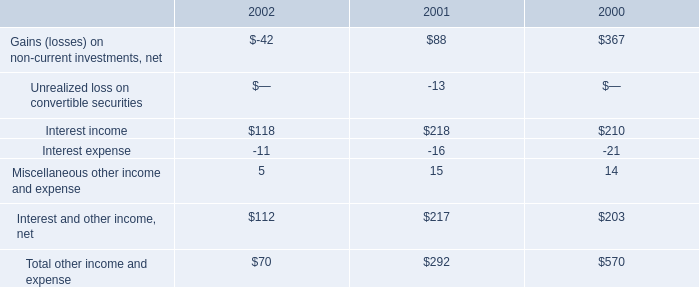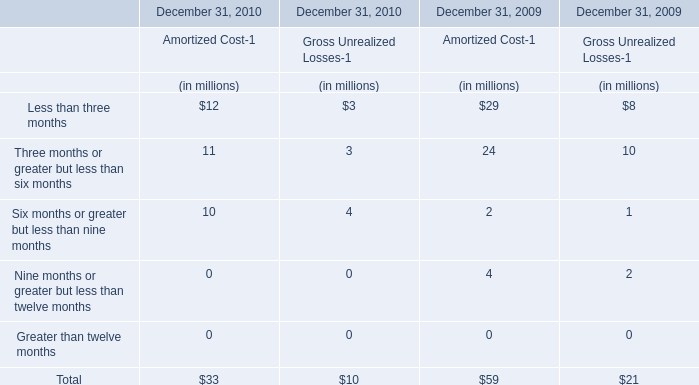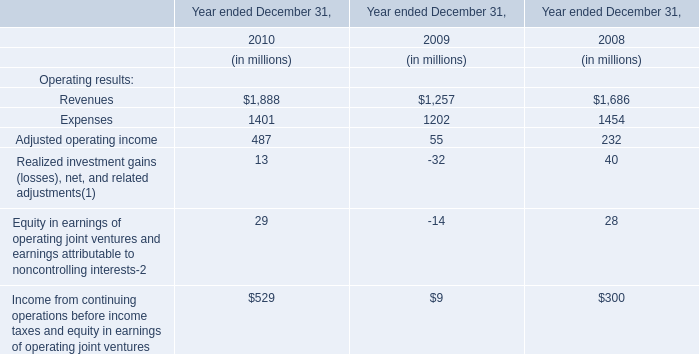Is the total amount of all elements for Amortized Cost-1 in 2010 greater than that in 2009? 
Answer: Yes. 